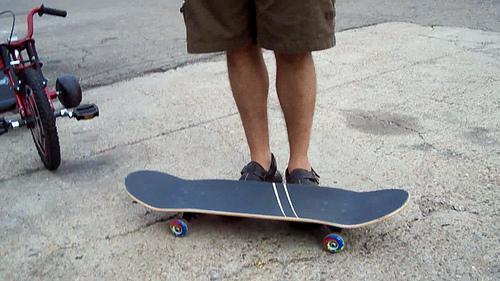How many people are in the photo?
Give a very brief answer. 1. How many wheels do you see?
Give a very brief answer. 3. How many people can be seen?
Give a very brief answer. 1. 